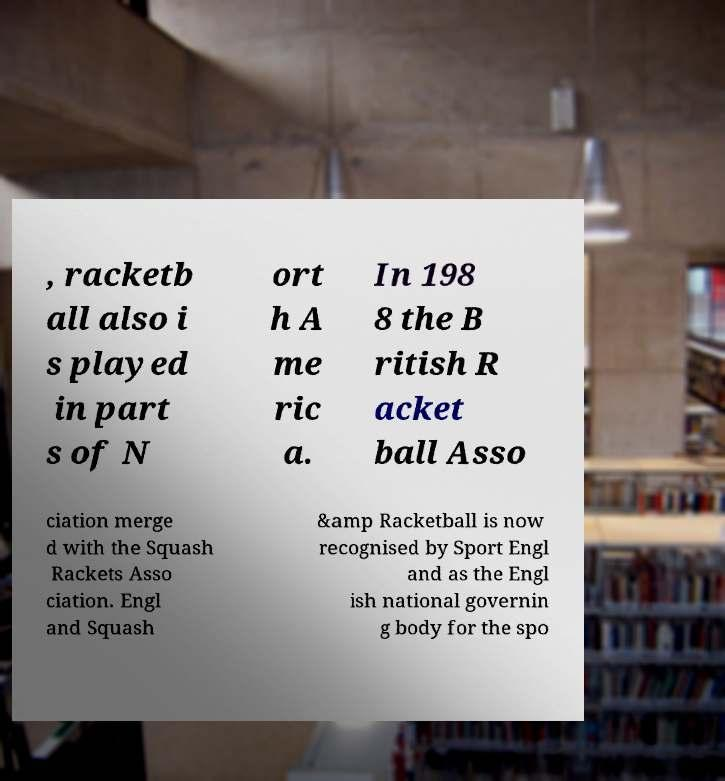Please identify and transcribe the text found in this image. , racketb all also i s played in part s of N ort h A me ric a. In 198 8 the B ritish R acket ball Asso ciation merge d with the Squash Rackets Asso ciation. Engl and Squash &amp Racketball is now recognised by Sport Engl and as the Engl ish national governin g body for the spo 